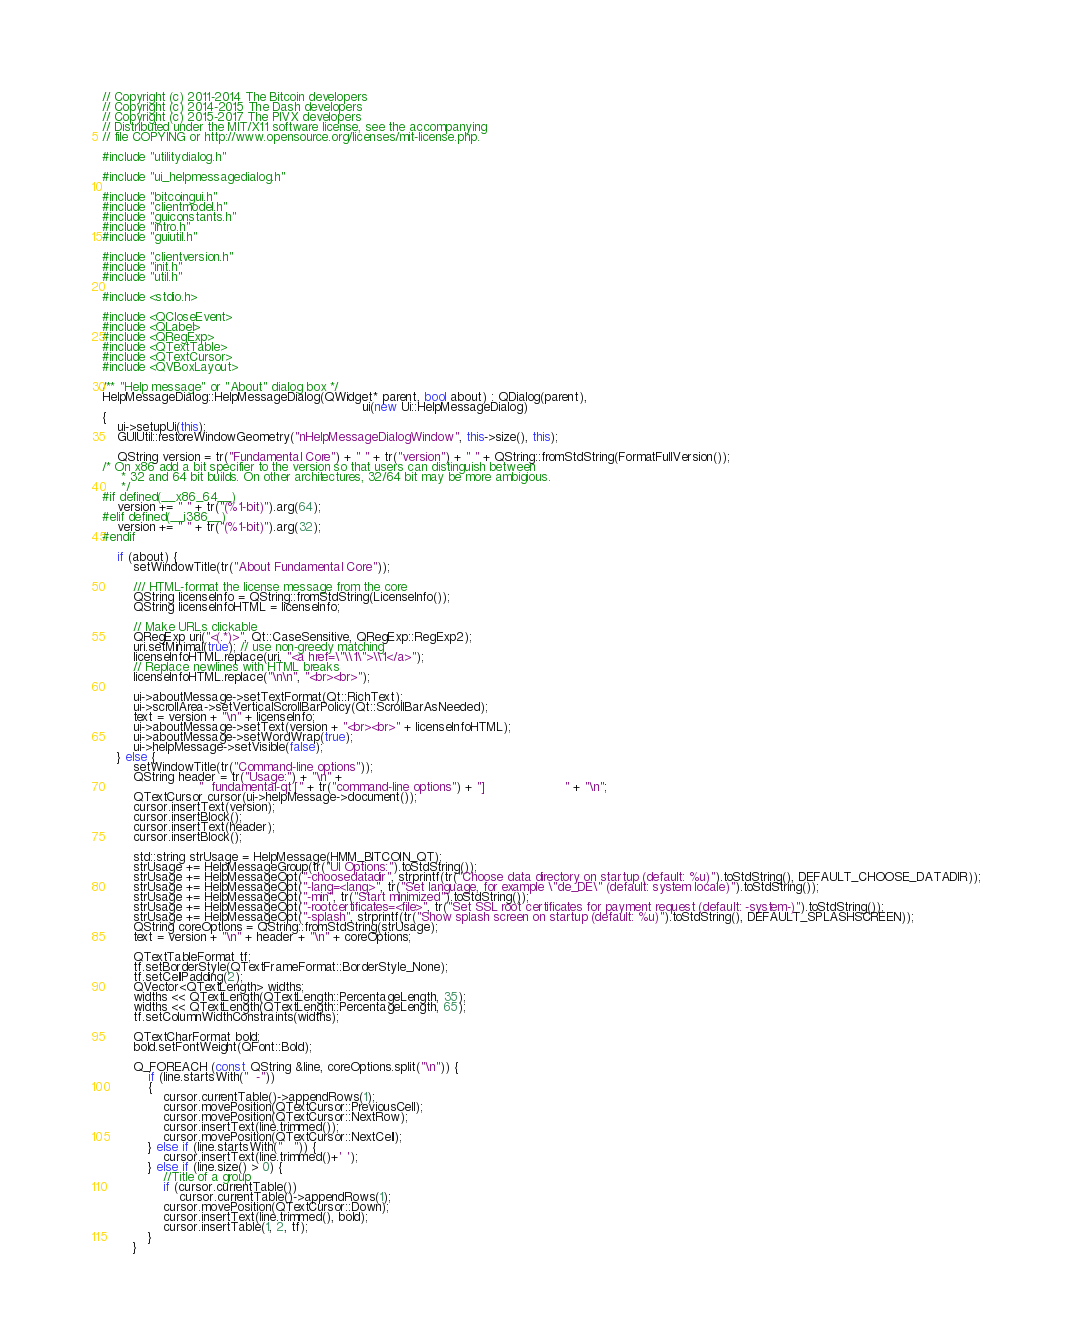<code> <loc_0><loc_0><loc_500><loc_500><_C++_>// Copyright (c) 2011-2014 The Bitcoin developers
// Copyright (c) 2014-2015 The Dash developers
// Copyright (c) 2015-2017 The PIVX developers
// Distributed under the MIT/X11 software license, see the accompanying
// file COPYING or http://www.opensource.org/licenses/mit-license.php.

#include "utilitydialog.h"

#include "ui_helpmessagedialog.h"

#include "bitcoingui.h"
#include "clientmodel.h"
#include "guiconstants.h"
#include "intro.h"
#include "guiutil.h"

#include "clientversion.h"
#include "init.h"
#include "util.h"

#include <stdio.h>

#include <QCloseEvent>
#include <QLabel>
#include <QRegExp>
#include <QTextTable>
#include <QTextCursor>
#include <QVBoxLayout>

/** "Help message" or "About" dialog box */
HelpMessageDialog::HelpMessageDialog(QWidget* parent, bool about) : QDialog(parent),
                                                                    ui(new Ui::HelpMessageDialog)
{
    ui->setupUi(this);
    GUIUtil::restoreWindowGeometry("nHelpMessageDialogWindow", this->size(), this);

    QString version = tr("Fundamental Core") + " " + tr("version") + " " + QString::fromStdString(FormatFullVersion());
/* On x86 add a bit specifier to the version so that users can distinguish between
     * 32 and 64 bit builds. On other architectures, 32/64 bit may be more ambigious.
     */
#if defined(__x86_64__)
    version += " " + tr("(%1-bit)").arg(64);
#elif defined(__i386__)
    version += " " + tr("(%1-bit)").arg(32);
#endif

    if (about) {
        setWindowTitle(tr("About Fundamental Core"));

        /// HTML-format the license message from the core
        QString licenseInfo = QString::fromStdString(LicenseInfo());
        QString licenseInfoHTML = licenseInfo;

        // Make URLs clickable
        QRegExp uri("<(.*)>", Qt::CaseSensitive, QRegExp::RegExp2);
        uri.setMinimal(true); // use non-greedy matching
        licenseInfoHTML.replace(uri, "<a href=\"\\1\">\\1</a>");
        // Replace newlines with HTML breaks
        licenseInfoHTML.replace("\n\n", "<br><br>");

        ui->aboutMessage->setTextFormat(Qt::RichText);
        ui->scrollArea->setVerticalScrollBarPolicy(Qt::ScrollBarAsNeeded);
        text = version + "\n" + licenseInfo;
        ui->aboutMessage->setText(version + "<br><br>" + licenseInfoHTML);
        ui->aboutMessage->setWordWrap(true);
        ui->helpMessage->setVisible(false);
    } else {
        setWindowTitle(tr("Command-line options"));
        QString header = tr("Usage:") + "\n" +
                         "  fundamental-qt [" + tr("command-line options") + "]                     " + "\n";
        QTextCursor cursor(ui->helpMessage->document());
        cursor.insertText(version);
        cursor.insertBlock();
        cursor.insertText(header);
        cursor.insertBlock();

        std::string strUsage = HelpMessage(HMM_BITCOIN_QT);
        strUsage += HelpMessageGroup(tr("UI Options:").toStdString());
        strUsage += HelpMessageOpt("-choosedatadir", strprintf(tr("Choose data directory on startup (default: %u)").toStdString(), DEFAULT_CHOOSE_DATADIR));
        strUsage += HelpMessageOpt("-lang=<lang>", tr("Set language, for example \"de_DE\" (default: system locale)").toStdString());
        strUsage += HelpMessageOpt("-min", tr("Start minimized").toStdString());
        strUsage += HelpMessageOpt("-rootcertificates=<file>", tr("Set SSL root certificates for payment request (default: -system-)").toStdString());
        strUsage += HelpMessageOpt("-splash", strprintf(tr("Show splash screen on startup (default: %u)").toStdString(), DEFAULT_SPLASHSCREEN));
        QString coreOptions = QString::fromStdString(strUsage);
        text = version + "\n" + header + "\n" + coreOptions;

        QTextTableFormat tf;
        tf.setBorderStyle(QTextFrameFormat::BorderStyle_None);
        tf.setCellPadding(2);
        QVector<QTextLength> widths;
        widths << QTextLength(QTextLength::PercentageLength, 35);
        widths << QTextLength(QTextLength::PercentageLength, 65);
        tf.setColumnWidthConstraints(widths);

        QTextCharFormat bold;
        bold.setFontWeight(QFont::Bold);

        Q_FOREACH (const QString &line, coreOptions.split("\n")) {
            if (line.startsWith("  -"))
            {
                cursor.currentTable()->appendRows(1);
                cursor.movePosition(QTextCursor::PreviousCell);
                cursor.movePosition(QTextCursor::NextRow);
                cursor.insertText(line.trimmed());
                cursor.movePosition(QTextCursor::NextCell);
            } else if (line.startsWith("   ")) {
                cursor.insertText(line.trimmed()+' ');
            } else if (line.size() > 0) {
                //Title of a group
                if (cursor.currentTable())
                    cursor.currentTable()->appendRows(1);
                cursor.movePosition(QTextCursor::Down);
                cursor.insertText(line.trimmed(), bold);
                cursor.insertTable(1, 2, tf);
            }
        }
</code> 